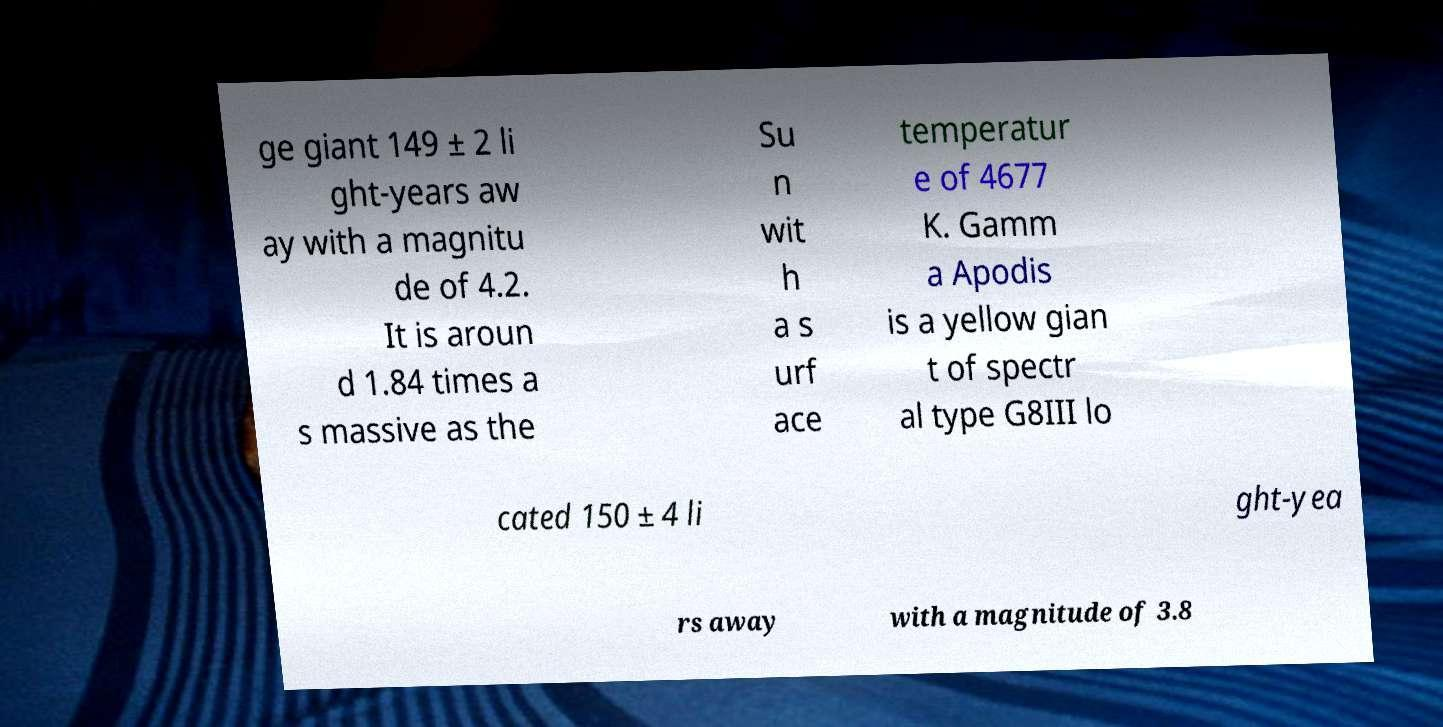Can you read and provide the text displayed in the image?This photo seems to have some interesting text. Can you extract and type it out for me? ge giant 149 ± 2 li ght-years aw ay with a magnitu de of 4.2. It is aroun d 1.84 times a s massive as the Su n wit h a s urf ace temperatur e of 4677 K. Gamm a Apodis is a yellow gian t of spectr al type G8III lo cated 150 ± 4 li ght-yea rs away with a magnitude of 3.8 